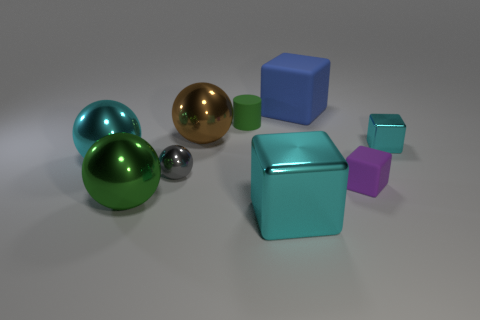Subtract all big green metallic balls. How many balls are left? 3 Subtract all gray balls. How many balls are left? 3 Add 1 yellow metallic cubes. How many objects exist? 10 Subtract 1 balls. How many balls are left? 3 Subtract all yellow cubes. Subtract all cyan balls. How many cubes are left? 4 Subtract all cylinders. How many objects are left? 8 Add 3 small cyan shiny cubes. How many small cyan shiny cubes are left? 4 Add 5 brown shiny cylinders. How many brown shiny cylinders exist? 5 Subtract 0 blue spheres. How many objects are left? 9 Subtract all small blue things. Subtract all blue blocks. How many objects are left? 8 